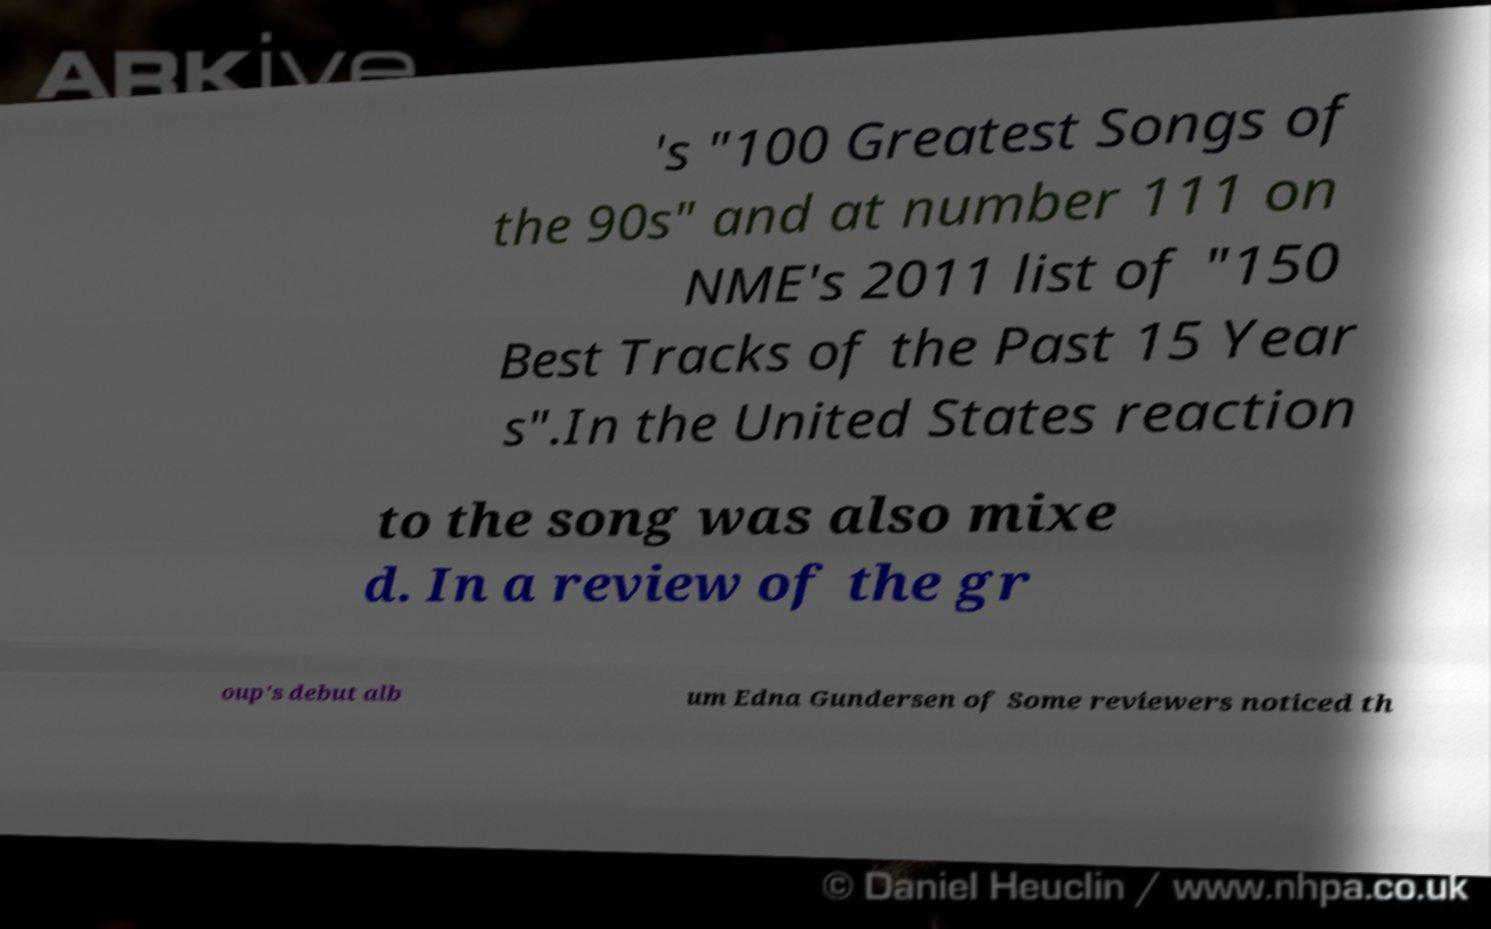Could you assist in decoding the text presented in this image and type it out clearly? 's "100 Greatest Songs of the 90s" and at number 111 on NME's 2011 list of "150 Best Tracks of the Past 15 Year s".In the United States reaction to the song was also mixe d. In a review of the gr oup's debut alb um Edna Gundersen of Some reviewers noticed th 